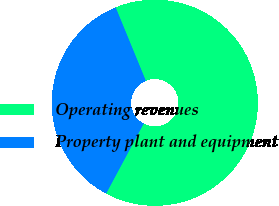Convert chart. <chart><loc_0><loc_0><loc_500><loc_500><pie_chart><fcel>Operating revenues<fcel>Property plant and equipment<nl><fcel>64.04%<fcel>35.96%<nl></chart> 